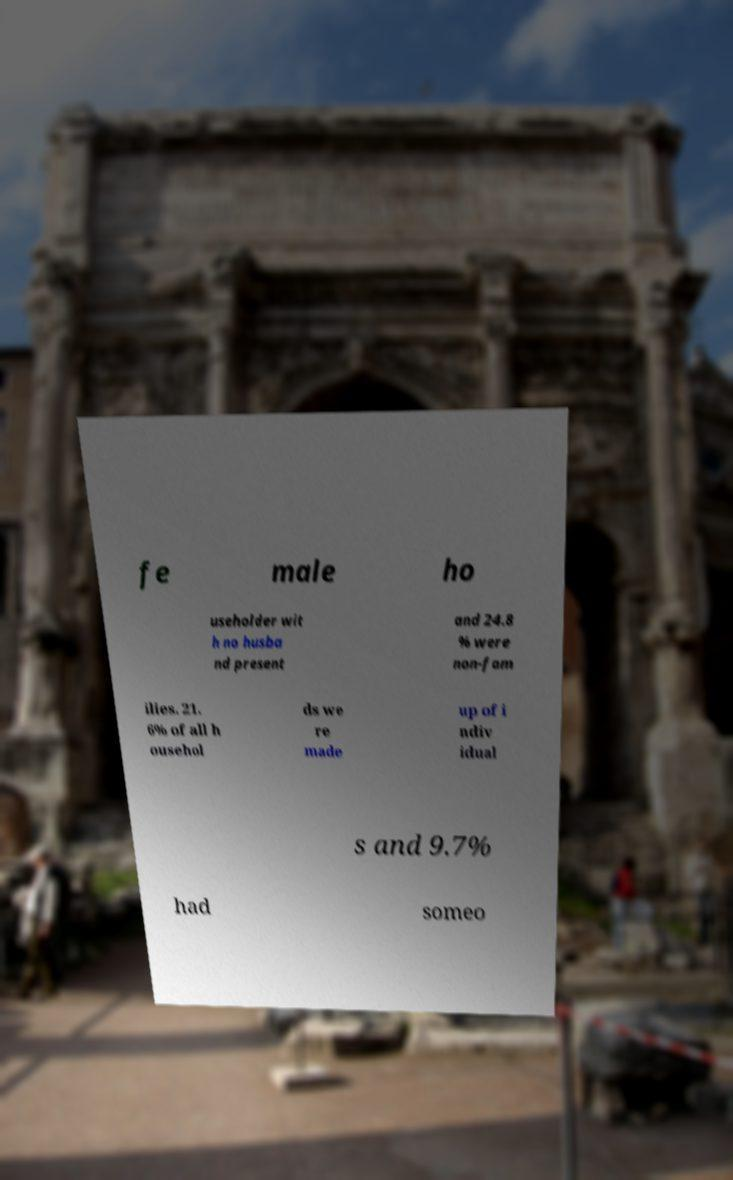Please read and relay the text visible in this image. What does it say? fe male ho useholder wit h no husba nd present and 24.8 % were non-fam ilies. 21. 6% of all h ousehol ds we re made up of i ndiv idual s and 9.7% had someo 